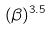<formula> <loc_0><loc_0><loc_500><loc_500>( \beta ) ^ { 3 . 5 }</formula> 